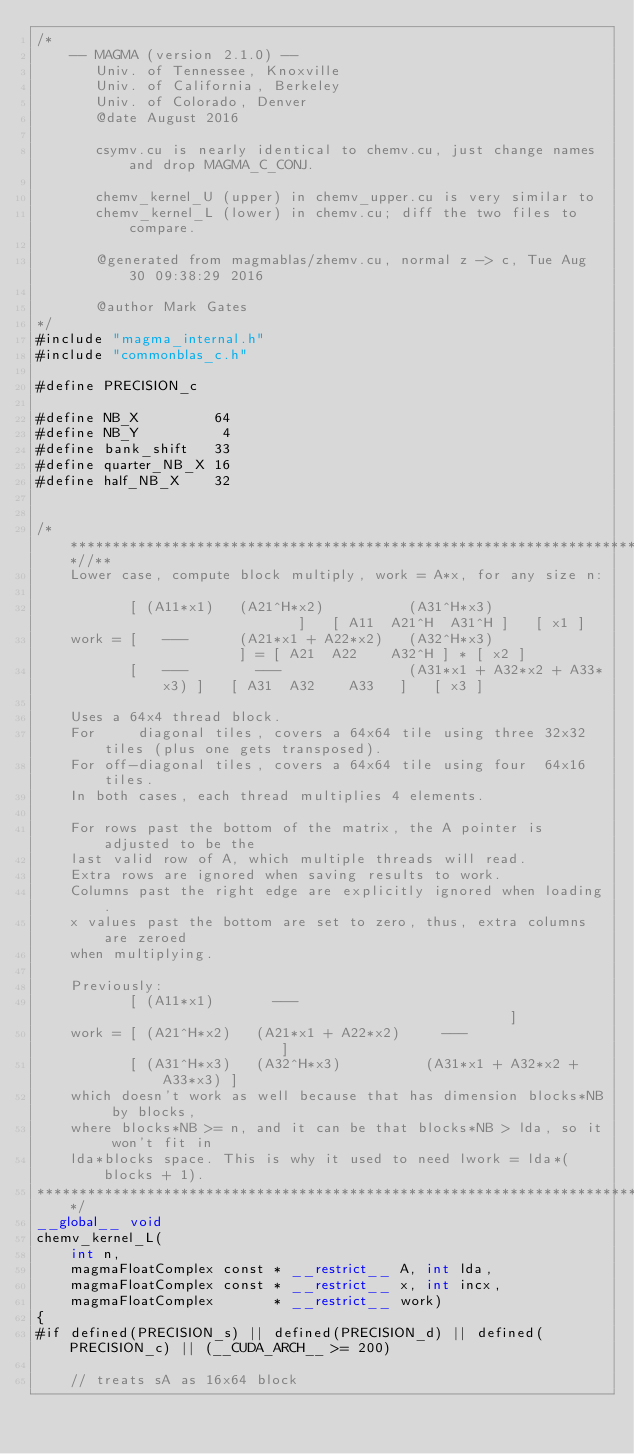<code> <loc_0><loc_0><loc_500><loc_500><_Cuda_>/*
    -- MAGMA (version 2.1.0) --
       Univ. of Tennessee, Knoxville
       Univ. of California, Berkeley
       Univ. of Colorado, Denver
       @date August 2016
       
       csymv.cu is nearly identical to chemv.cu, just change names and drop MAGMA_C_CONJ.
       
       chemv_kernel_U (upper) in chemv_upper.cu is very similar to
       chemv_kernel_L (lower) in chemv.cu; diff the two files to compare.
       
       @generated from magmablas/zhemv.cu, normal z -> c, Tue Aug 30 09:38:29 2016
       
       @author Mark Gates
*/
#include "magma_internal.h"
#include "commonblas_c.h"

#define PRECISION_c

#define NB_X         64
#define NB_Y          4
#define bank_shift   33
#define quarter_NB_X 16
#define half_NB_X    32


/***************************************************************************//**
    Lower case, compute block multiply, work = A*x, for any size n:
    
           [ (A11*x1)   (A21^H*x2)          (A31^H*x3)                 ]   [ A11  A21^H  A31^H ]   [ x1 ]
    work = [   ---      (A21*x1 + A22*x2)   (A32^H*x3)                 ] = [ A21  A22    A32^H ] * [ x2 ]
           [   ---        ---               (A31*x1 + A32*x2 + A33*x3) ]   [ A31  A32    A33   ]   [ x3 ]
    
    Uses a 64x4 thread block.
    For     diagonal tiles, covers a 64x64 tile using three 32x32 tiles (plus one gets transposed).
    For off-diagonal tiles, covers a 64x64 tile using four  64x16 tiles.
    In both cases, each thread multiplies 4 elements.
    
    For rows past the bottom of the matrix, the A pointer is adjusted to be the
    last valid row of A, which multiple threads will read.
    Extra rows are ignored when saving results to work.
    Columns past the right edge are explicitly ignored when loading.
    x values past the bottom are set to zero, thus, extra columns are zeroed
    when multiplying.
    
    Previously:
           [ (A11*x1)       ---                                          ]
    work = [ (A21^H*x2)   (A21*x1 + A22*x2)     ---                      ]
           [ (A31^H*x3)   (A32^H*x3)          (A31*x1 + A32*x2 + A33*x3) ]
    which doesn't work as well because that has dimension blocks*NB by blocks,
    where blocks*NB >= n, and it can be that blocks*NB > lda, so it won't fit in
    lda*blocks space. This is why it used to need lwork = lda*(blocks + 1).
*******************************************************************************/
__global__ void
chemv_kernel_L(
    int n,
    magmaFloatComplex const * __restrict__ A, int lda,
    magmaFloatComplex const * __restrict__ x, int incx,
    magmaFloatComplex       * __restrict__ work)
{
#if defined(PRECISION_s) || defined(PRECISION_d) || defined(PRECISION_c) || (__CUDA_ARCH__ >= 200)

    // treats sA as 16x64 block</code> 